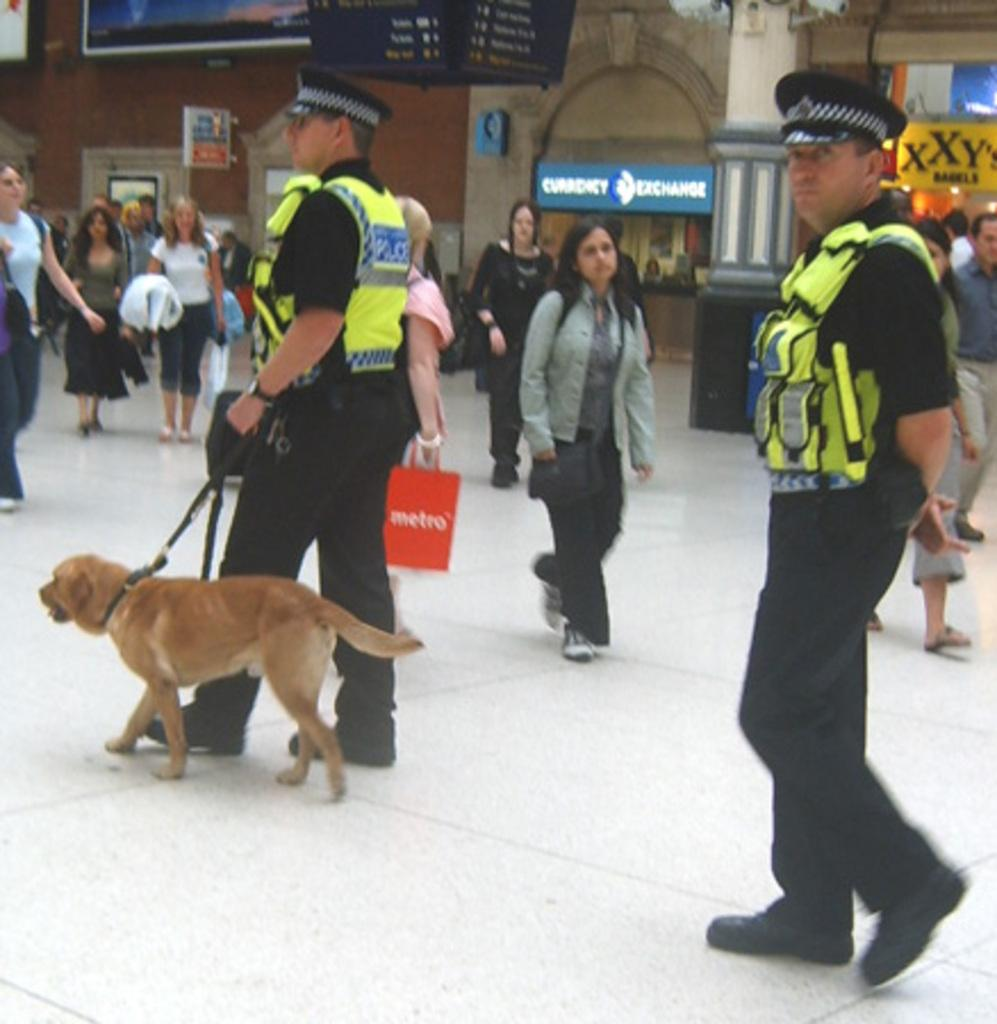What are the people in the image doing? There are persons walking on the floor in the image. Can you identify any specific individuals in the image? Yes, there are two policemen in the image. What is the man holding in his hand? The man is holding a dog's leash in his hand. What architectural features can be seen in the image? There are pillars in the image. What type of signage is present in the image? There are hoardings in the image. What type of kettle is visible on the policemen's heads in the image? There is no kettle present on the policemen's heads in the image. What is the sock used for in the image? There is no sock present in the image. 